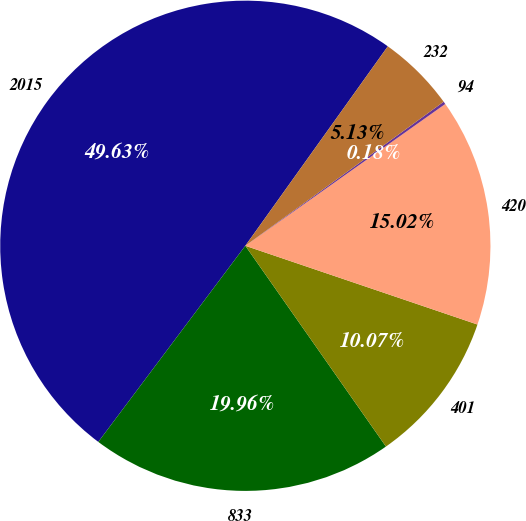Convert chart. <chart><loc_0><loc_0><loc_500><loc_500><pie_chart><fcel>2015<fcel>833<fcel>401<fcel>420<fcel>94<fcel>232<nl><fcel>49.63%<fcel>19.96%<fcel>10.07%<fcel>15.02%<fcel>0.18%<fcel>5.13%<nl></chart> 